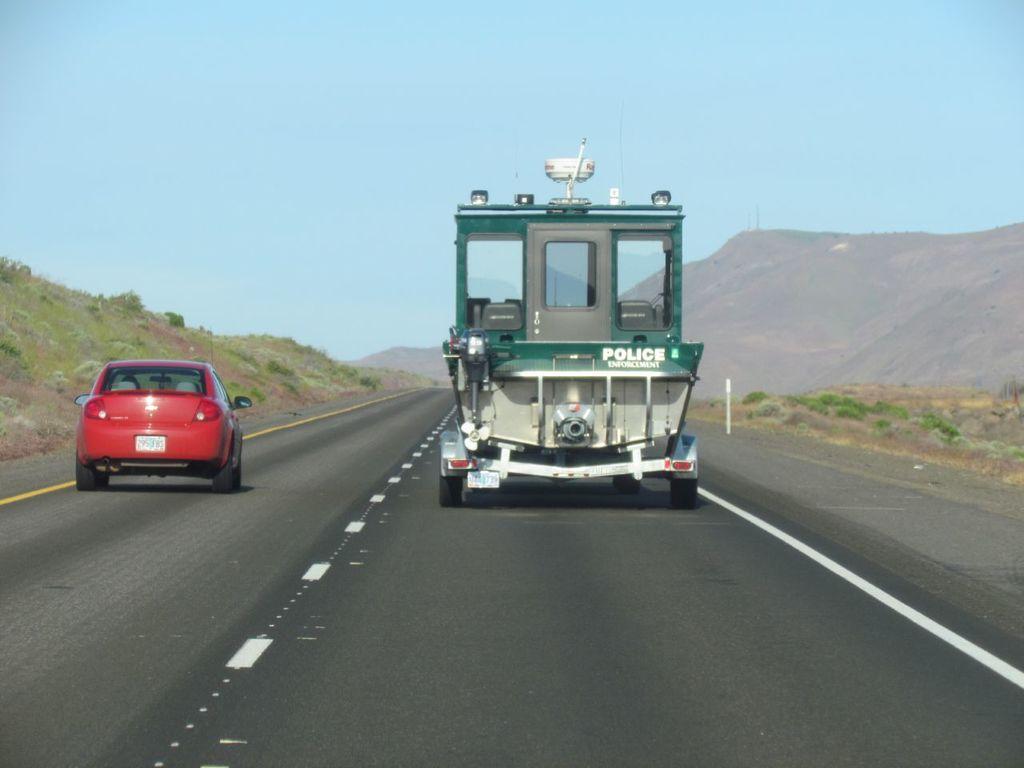Please provide a concise description of this image. This picture shows a car and a vehicle moving on the road and we see few plants and a blue cloudy sky and we see a hill. Car is red in color. 